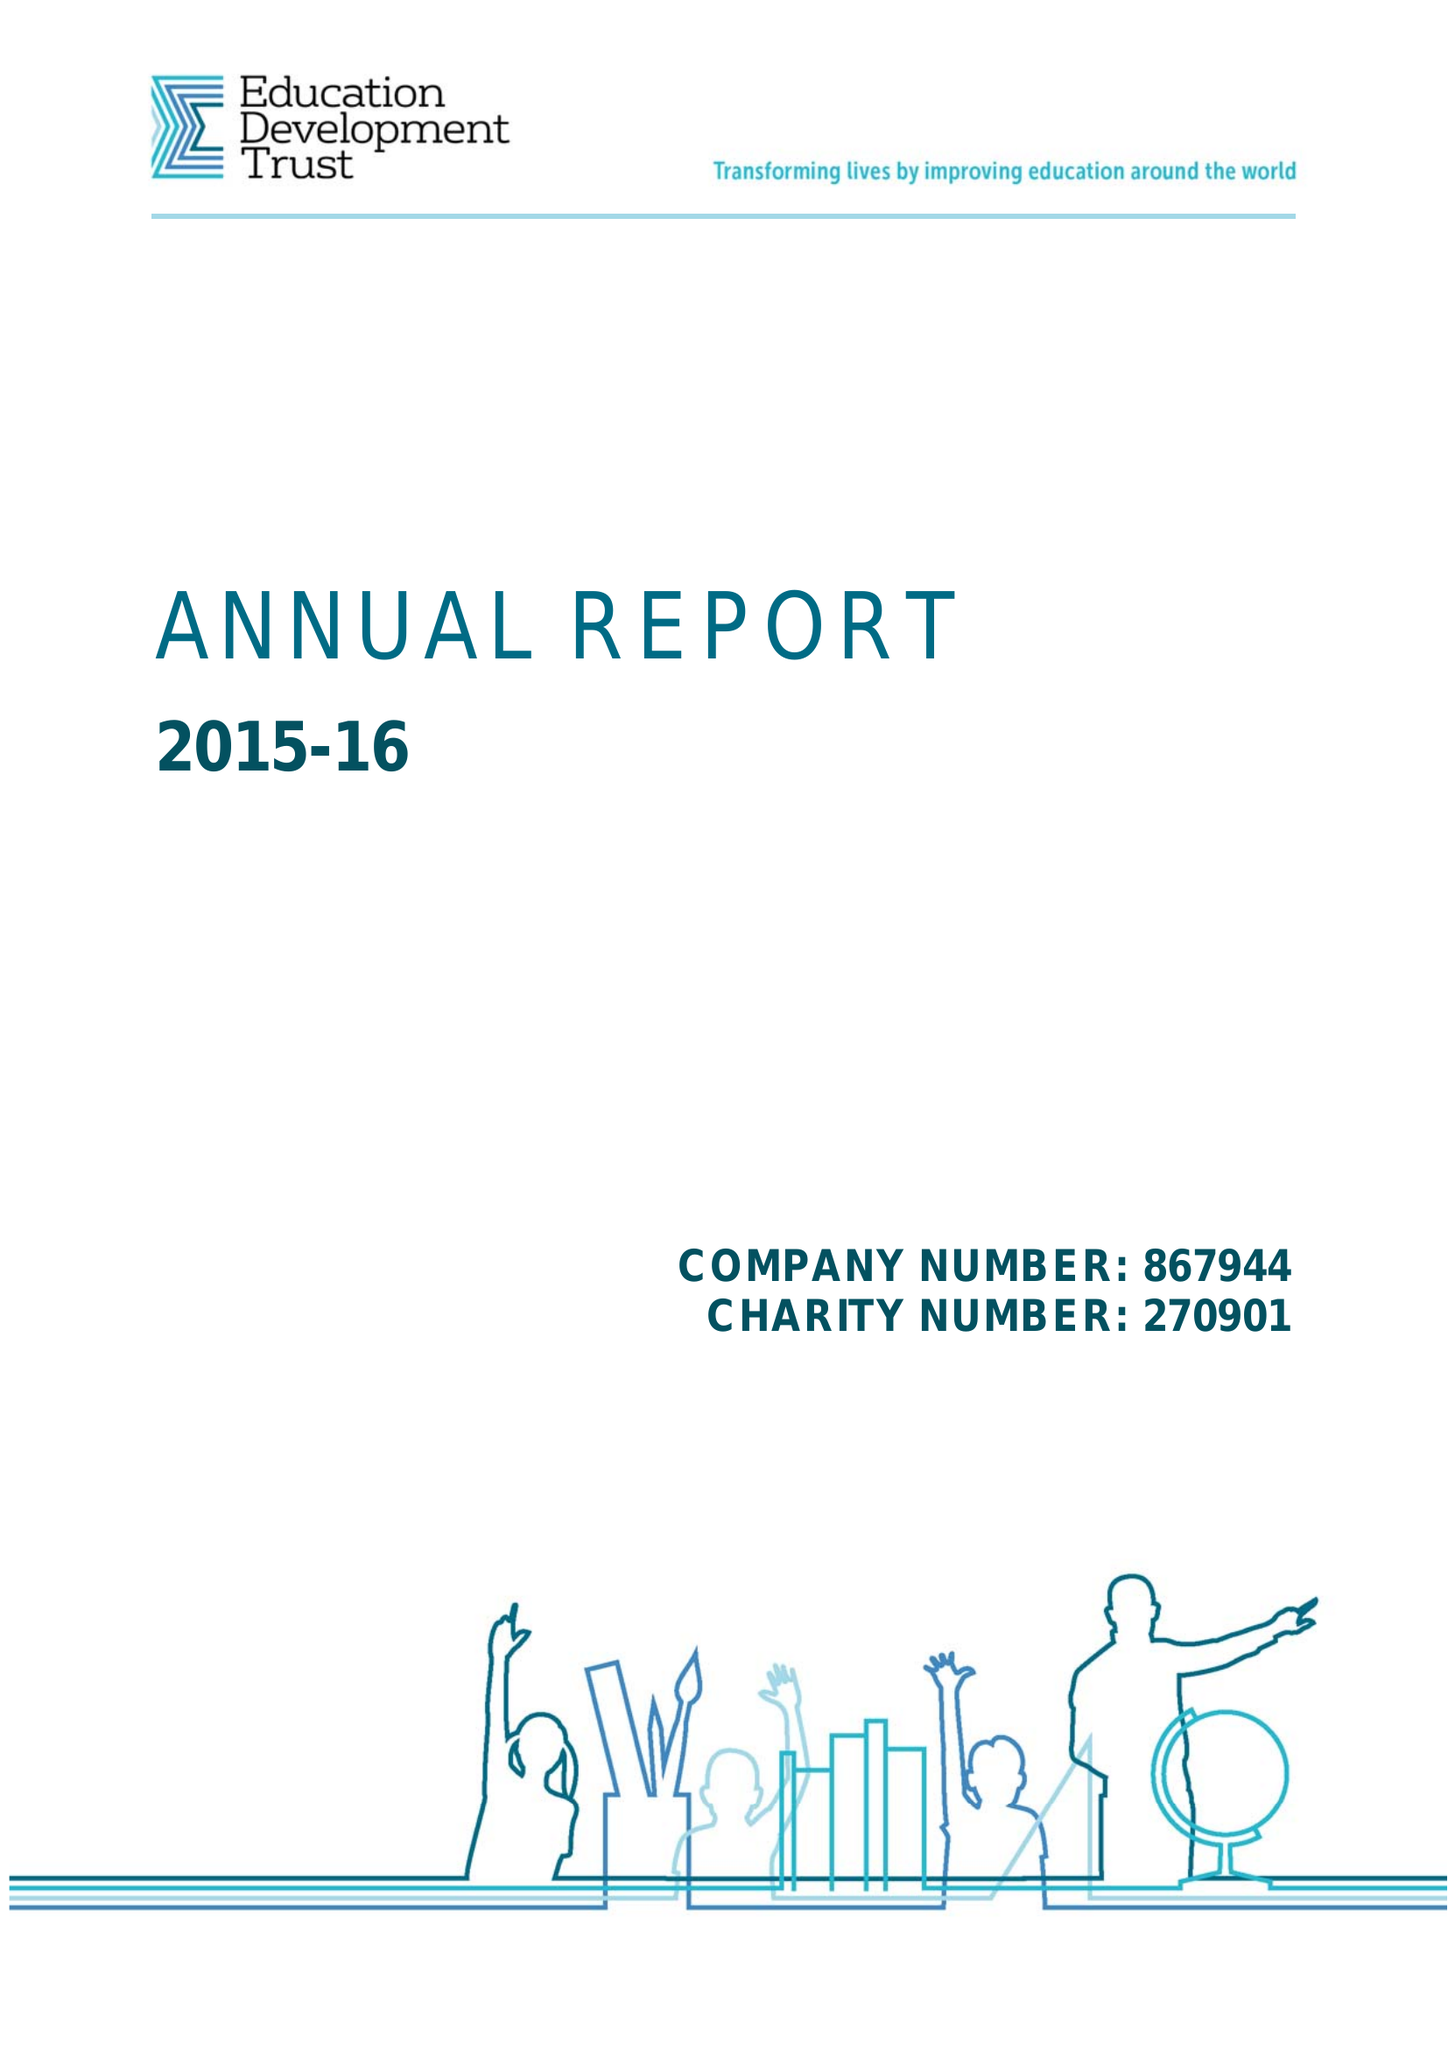What is the value for the charity_number?
Answer the question using a single word or phrase. 270901 